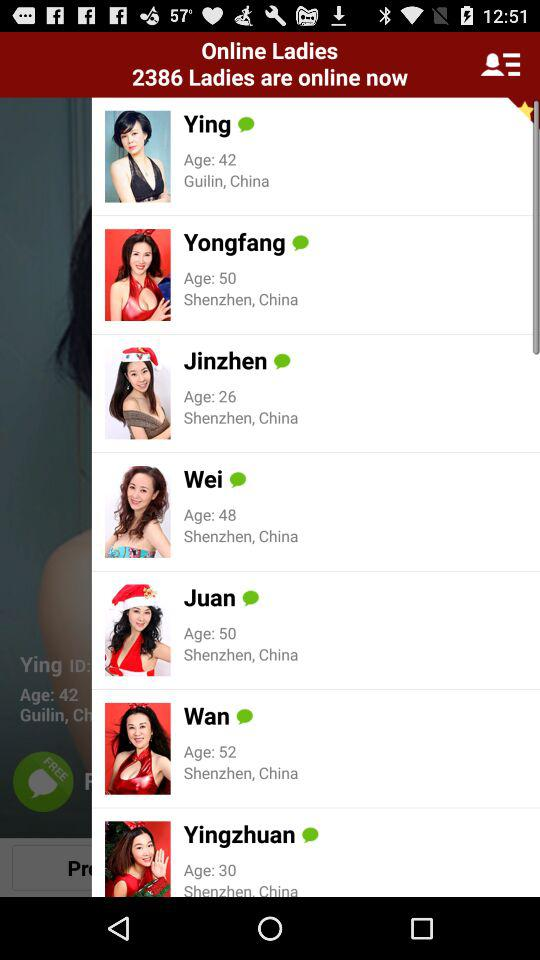How many ladies are online now? The number of ladies that are online now is 2386. 